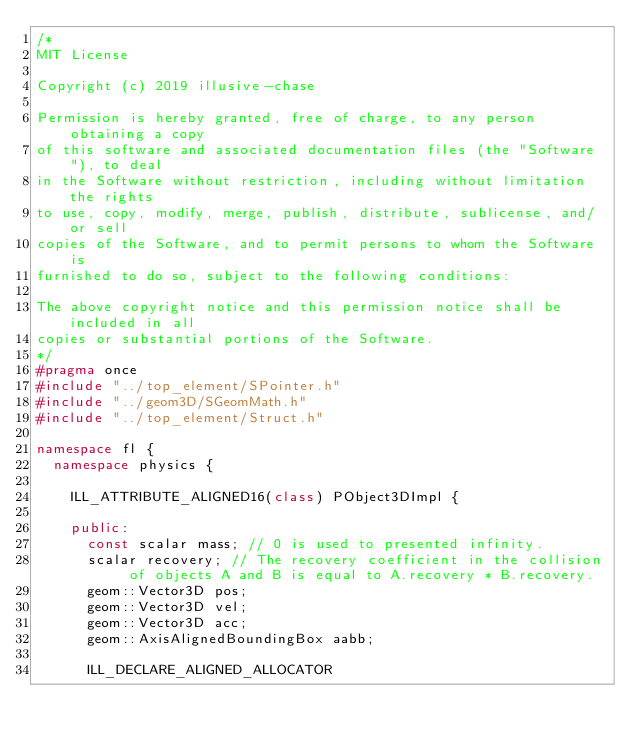<code> <loc_0><loc_0><loc_500><loc_500><_C++_>/*
MIT License

Copyright (c) 2019 illusive-chase

Permission is hereby granted, free of charge, to any person obtaining a copy
of this software and associated documentation files (the "Software"), to deal
in the Software without restriction, including without limitation the rights
to use, copy, modify, merge, publish, distribute, sublicense, and/or sell
copies of the Software, and to permit persons to whom the Software is
furnished to do so, subject to the following conditions:

The above copyright notice and this permission notice shall be included in all
copies or substantial portions of the Software.
*/
#pragma once
#include "../top_element/SPointer.h"
#include "../geom3D/SGeomMath.h"
#include "../top_element/Struct.h"

namespace fl {
	namespace physics {

		ILL_ATTRIBUTE_ALIGNED16(class) PObject3DImpl {

		public:
			const scalar mass; // 0 is used to presented infinity.
			scalar recovery; // The recovery coefficient in the collision of objects A and B is equal to A.recovery * B.recovery.
			geom::Vector3D pos;
			geom::Vector3D vel;
			geom::Vector3D acc;
			geom::AxisAlignedBoundingBox aabb;

			ILL_DECLARE_ALIGNED_ALLOCATOR
</code> 